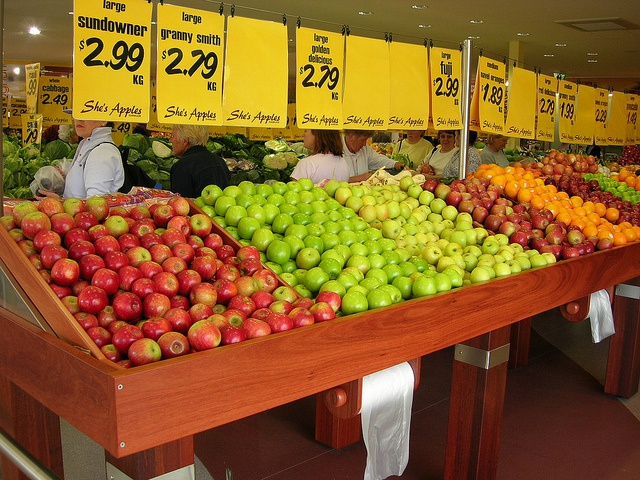Describe the objects in this image and their specific colors. I can see apple in darkgreen, brown, maroon, and olive tones, apple in darkgreen, khaki, and olive tones, people in darkgreen, darkgray, black, tan, and brown tones, orange in darkgreen, orange, red, and maroon tones, and people in darkgreen, black, olive, and maroon tones in this image. 